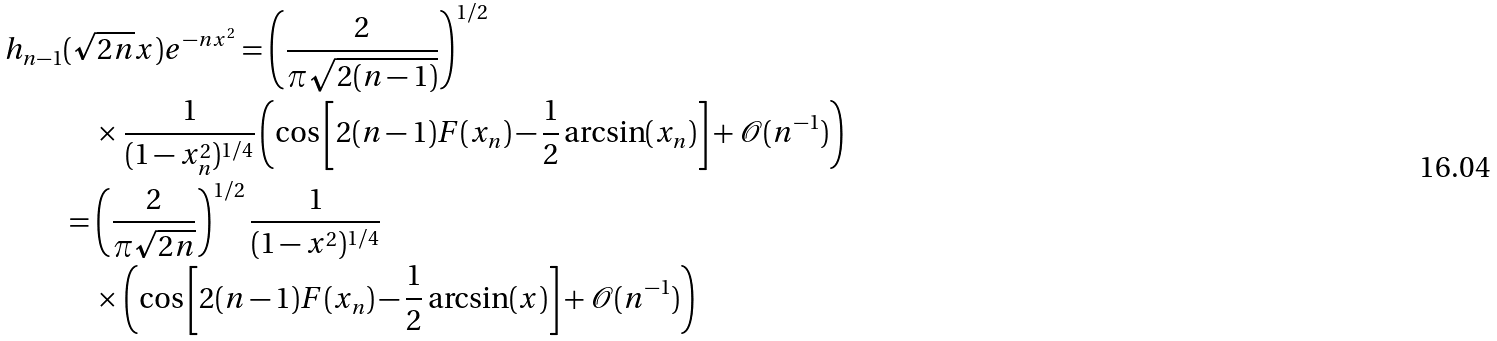Convert formula to latex. <formula><loc_0><loc_0><loc_500><loc_500>h _ { n - 1 } & ( \sqrt { 2 n } x ) e ^ { - n x ^ { 2 } } = \left ( \frac { 2 } { \pi \sqrt { 2 ( n - 1 ) } } \right ) ^ { 1 / 2 } \\ & \quad \times \frac { 1 } { ( 1 - x _ { n } ^ { 2 } ) ^ { 1 / 4 } } \left ( \cos \left [ 2 ( n - 1 ) F ( x _ { n } ) - \frac { 1 } { 2 } \arcsin ( x _ { n } ) \right ] + \mathcal { O } ( n ^ { - 1 } ) \right ) \\ & = \left ( \frac { 2 } { \pi \sqrt { 2 n } } \right ) ^ { 1 / 2 } \frac { 1 } { ( 1 - x ^ { 2 } ) ^ { 1 / 4 } } \\ & \quad \times \left ( \cos \left [ 2 ( n - 1 ) F ( x _ { n } ) - \frac { 1 } { 2 } \arcsin ( x ) \right ] + \mathcal { O } ( n ^ { - 1 } ) \right )</formula> 